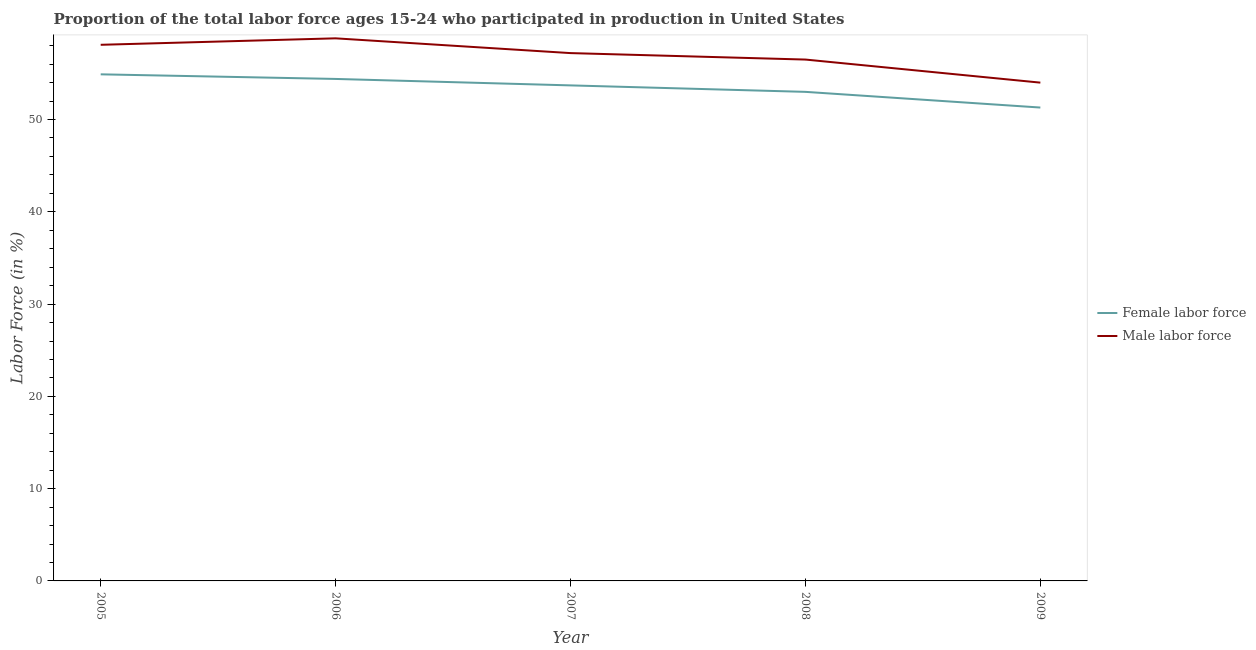How many different coloured lines are there?
Provide a short and direct response. 2. Is the number of lines equal to the number of legend labels?
Ensure brevity in your answer.  Yes. What is the percentage of female labor force in 2007?
Ensure brevity in your answer.  53.7. Across all years, what is the maximum percentage of female labor force?
Your response must be concise. 54.9. Across all years, what is the minimum percentage of female labor force?
Your response must be concise. 51.3. What is the total percentage of male labour force in the graph?
Your answer should be compact. 284.6. What is the difference between the percentage of male labour force in 2007 and that in 2008?
Give a very brief answer. 0.7. What is the difference between the percentage of male labour force in 2008 and the percentage of female labor force in 2006?
Your answer should be very brief. 2.1. What is the average percentage of male labour force per year?
Your answer should be very brief. 56.92. In the year 2006, what is the difference between the percentage of male labour force and percentage of female labor force?
Provide a short and direct response. 4.4. What is the ratio of the percentage of male labour force in 2005 to that in 2008?
Make the answer very short. 1.03. What is the difference between the highest and the lowest percentage of female labor force?
Ensure brevity in your answer.  3.6. Does the percentage of male labour force monotonically increase over the years?
Make the answer very short. No. Is the percentage of male labour force strictly less than the percentage of female labor force over the years?
Offer a terse response. No. How many years are there in the graph?
Keep it short and to the point. 5. Are the values on the major ticks of Y-axis written in scientific E-notation?
Your response must be concise. No. Where does the legend appear in the graph?
Your answer should be very brief. Center right. How are the legend labels stacked?
Your response must be concise. Vertical. What is the title of the graph?
Offer a very short reply. Proportion of the total labor force ages 15-24 who participated in production in United States. What is the label or title of the X-axis?
Provide a succinct answer. Year. What is the label or title of the Y-axis?
Your answer should be very brief. Labor Force (in %). What is the Labor Force (in %) in Female labor force in 2005?
Offer a very short reply. 54.9. What is the Labor Force (in %) of Male labor force in 2005?
Your answer should be very brief. 58.1. What is the Labor Force (in %) in Female labor force in 2006?
Offer a very short reply. 54.4. What is the Labor Force (in %) in Male labor force in 2006?
Provide a succinct answer. 58.8. What is the Labor Force (in %) of Female labor force in 2007?
Offer a terse response. 53.7. What is the Labor Force (in %) in Male labor force in 2007?
Your answer should be compact. 57.2. What is the Labor Force (in %) in Female labor force in 2008?
Ensure brevity in your answer.  53. What is the Labor Force (in %) of Male labor force in 2008?
Keep it short and to the point. 56.5. What is the Labor Force (in %) of Female labor force in 2009?
Ensure brevity in your answer.  51.3. What is the Labor Force (in %) of Male labor force in 2009?
Keep it short and to the point. 54. Across all years, what is the maximum Labor Force (in %) in Female labor force?
Your answer should be very brief. 54.9. Across all years, what is the maximum Labor Force (in %) of Male labor force?
Your response must be concise. 58.8. Across all years, what is the minimum Labor Force (in %) of Female labor force?
Offer a terse response. 51.3. What is the total Labor Force (in %) in Female labor force in the graph?
Make the answer very short. 267.3. What is the total Labor Force (in %) in Male labor force in the graph?
Keep it short and to the point. 284.6. What is the difference between the Labor Force (in %) in Female labor force in 2005 and that in 2006?
Keep it short and to the point. 0.5. What is the difference between the Labor Force (in %) in Female labor force in 2005 and that in 2008?
Give a very brief answer. 1.9. What is the difference between the Labor Force (in %) in Male labor force in 2005 and that in 2008?
Make the answer very short. 1.6. What is the difference between the Labor Force (in %) of Male labor force in 2005 and that in 2009?
Provide a short and direct response. 4.1. What is the difference between the Labor Force (in %) of Female labor force in 2006 and that in 2007?
Provide a succinct answer. 0.7. What is the difference between the Labor Force (in %) in Male labor force in 2006 and that in 2007?
Ensure brevity in your answer.  1.6. What is the difference between the Labor Force (in %) in Female labor force in 2006 and that in 2009?
Your answer should be compact. 3.1. What is the difference between the Labor Force (in %) of Female labor force in 2007 and that in 2009?
Make the answer very short. 2.4. What is the difference between the Labor Force (in %) in Male labor force in 2007 and that in 2009?
Your answer should be very brief. 3.2. What is the difference between the Labor Force (in %) in Male labor force in 2008 and that in 2009?
Provide a succinct answer. 2.5. What is the difference between the Labor Force (in %) in Female labor force in 2005 and the Labor Force (in %) in Male labor force in 2006?
Offer a very short reply. -3.9. What is the difference between the Labor Force (in %) of Female labor force in 2005 and the Labor Force (in %) of Male labor force in 2008?
Give a very brief answer. -1.6. What is the difference between the Labor Force (in %) of Female labor force in 2006 and the Labor Force (in %) of Male labor force in 2007?
Ensure brevity in your answer.  -2.8. What is the difference between the Labor Force (in %) of Female labor force in 2006 and the Labor Force (in %) of Male labor force in 2009?
Make the answer very short. 0.4. What is the difference between the Labor Force (in %) of Female labor force in 2008 and the Labor Force (in %) of Male labor force in 2009?
Give a very brief answer. -1. What is the average Labor Force (in %) in Female labor force per year?
Your response must be concise. 53.46. What is the average Labor Force (in %) in Male labor force per year?
Provide a short and direct response. 56.92. In the year 2005, what is the difference between the Labor Force (in %) in Female labor force and Labor Force (in %) in Male labor force?
Give a very brief answer. -3.2. In the year 2008, what is the difference between the Labor Force (in %) of Female labor force and Labor Force (in %) of Male labor force?
Give a very brief answer. -3.5. What is the ratio of the Labor Force (in %) of Female labor force in 2005 to that in 2006?
Make the answer very short. 1.01. What is the ratio of the Labor Force (in %) in Female labor force in 2005 to that in 2007?
Your answer should be very brief. 1.02. What is the ratio of the Labor Force (in %) of Male labor force in 2005 to that in 2007?
Your answer should be compact. 1.02. What is the ratio of the Labor Force (in %) in Female labor force in 2005 to that in 2008?
Your answer should be compact. 1.04. What is the ratio of the Labor Force (in %) in Male labor force in 2005 to that in 2008?
Your response must be concise. 1.03. What is the ratio of the Labor Force (in %) of Female labor force in 2005 to that in 2009?
Provide a succinct answer. 1.07. What is the ratio of the Labor Force (in %) in Male labor force in 2005 to that in 2009?
Ensure brevity in your answer.  1.08. What is the ratio of the Labor Force (in %) of Male labor force in 2006 to that in 2007?
Make the answer very short. 1.03. What is the ratio of the Labor Force (in %) of Female labor force in 2006 to that in 2008?
Keep it short and to the point. 1.03. What is the ratio of the Labor Force (in %) of Male labor force in 2006 to that in 2008?
Give a very brief answer. 1.04. What is the ratio of the Labor Force (in %) of Female labor force in 2006 to that in 2009?
Your answer should be compact. 1.06. What is the ratio of the Labor Force (in %) of Male labor force in 2006 to that in 2009?
Offer a very short reply. 1.09. What is the ratio of the Labor Force (in %) of Female labor force in 2007 to that in 2008?
Your response must be concise. 1.01. What is the ratio of the Labor Force (in %) of Male labor force in 2007 to that in 2008?
Your answer should be compact. 1.01. What is the ratio of the Labor Force (in %) in Female labor force in 2007 to that in 2009?
Provide a short and direct response. 1.05. What is the ratio of the Labor Force (in %) of Male labor force in 2007 to that in 2009?
Your response must be concise. 1.06. What is the ratio of the Labor Force (in %) in Female labor force in 2008 to that in 2009?
Ensure brevity in your answer.  1.03. What is the ratio of the Labor Force (in %) of Male labor force in 2008 to that in 2009?
Give a very brief answer. 1.05. What is the difference between the highest and the second highest Labor Force (in %) in Male labor force?
Offer a terse response. 0.7. What is the difference between the highest and the lowest Labor Force (in %) of Female labor force?
Ensure brevity in your answer.  3.6. 